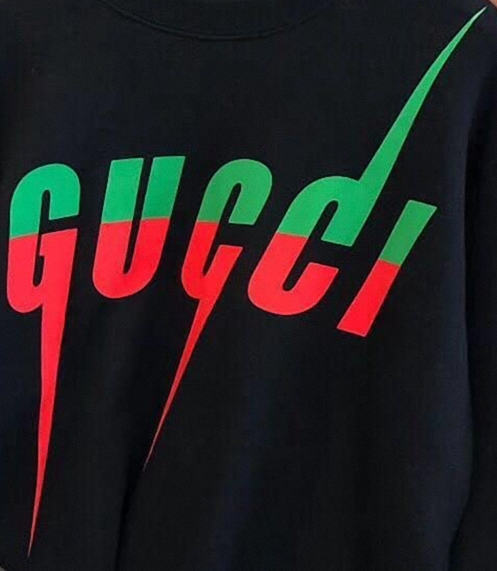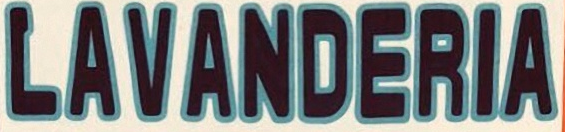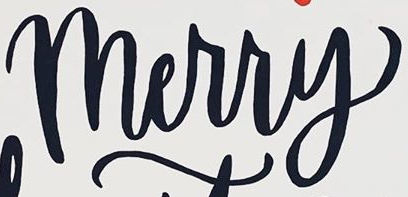Read the text content from these images in order, separated by a semicolon. GUCCI; LAVANDERIA; Merry 